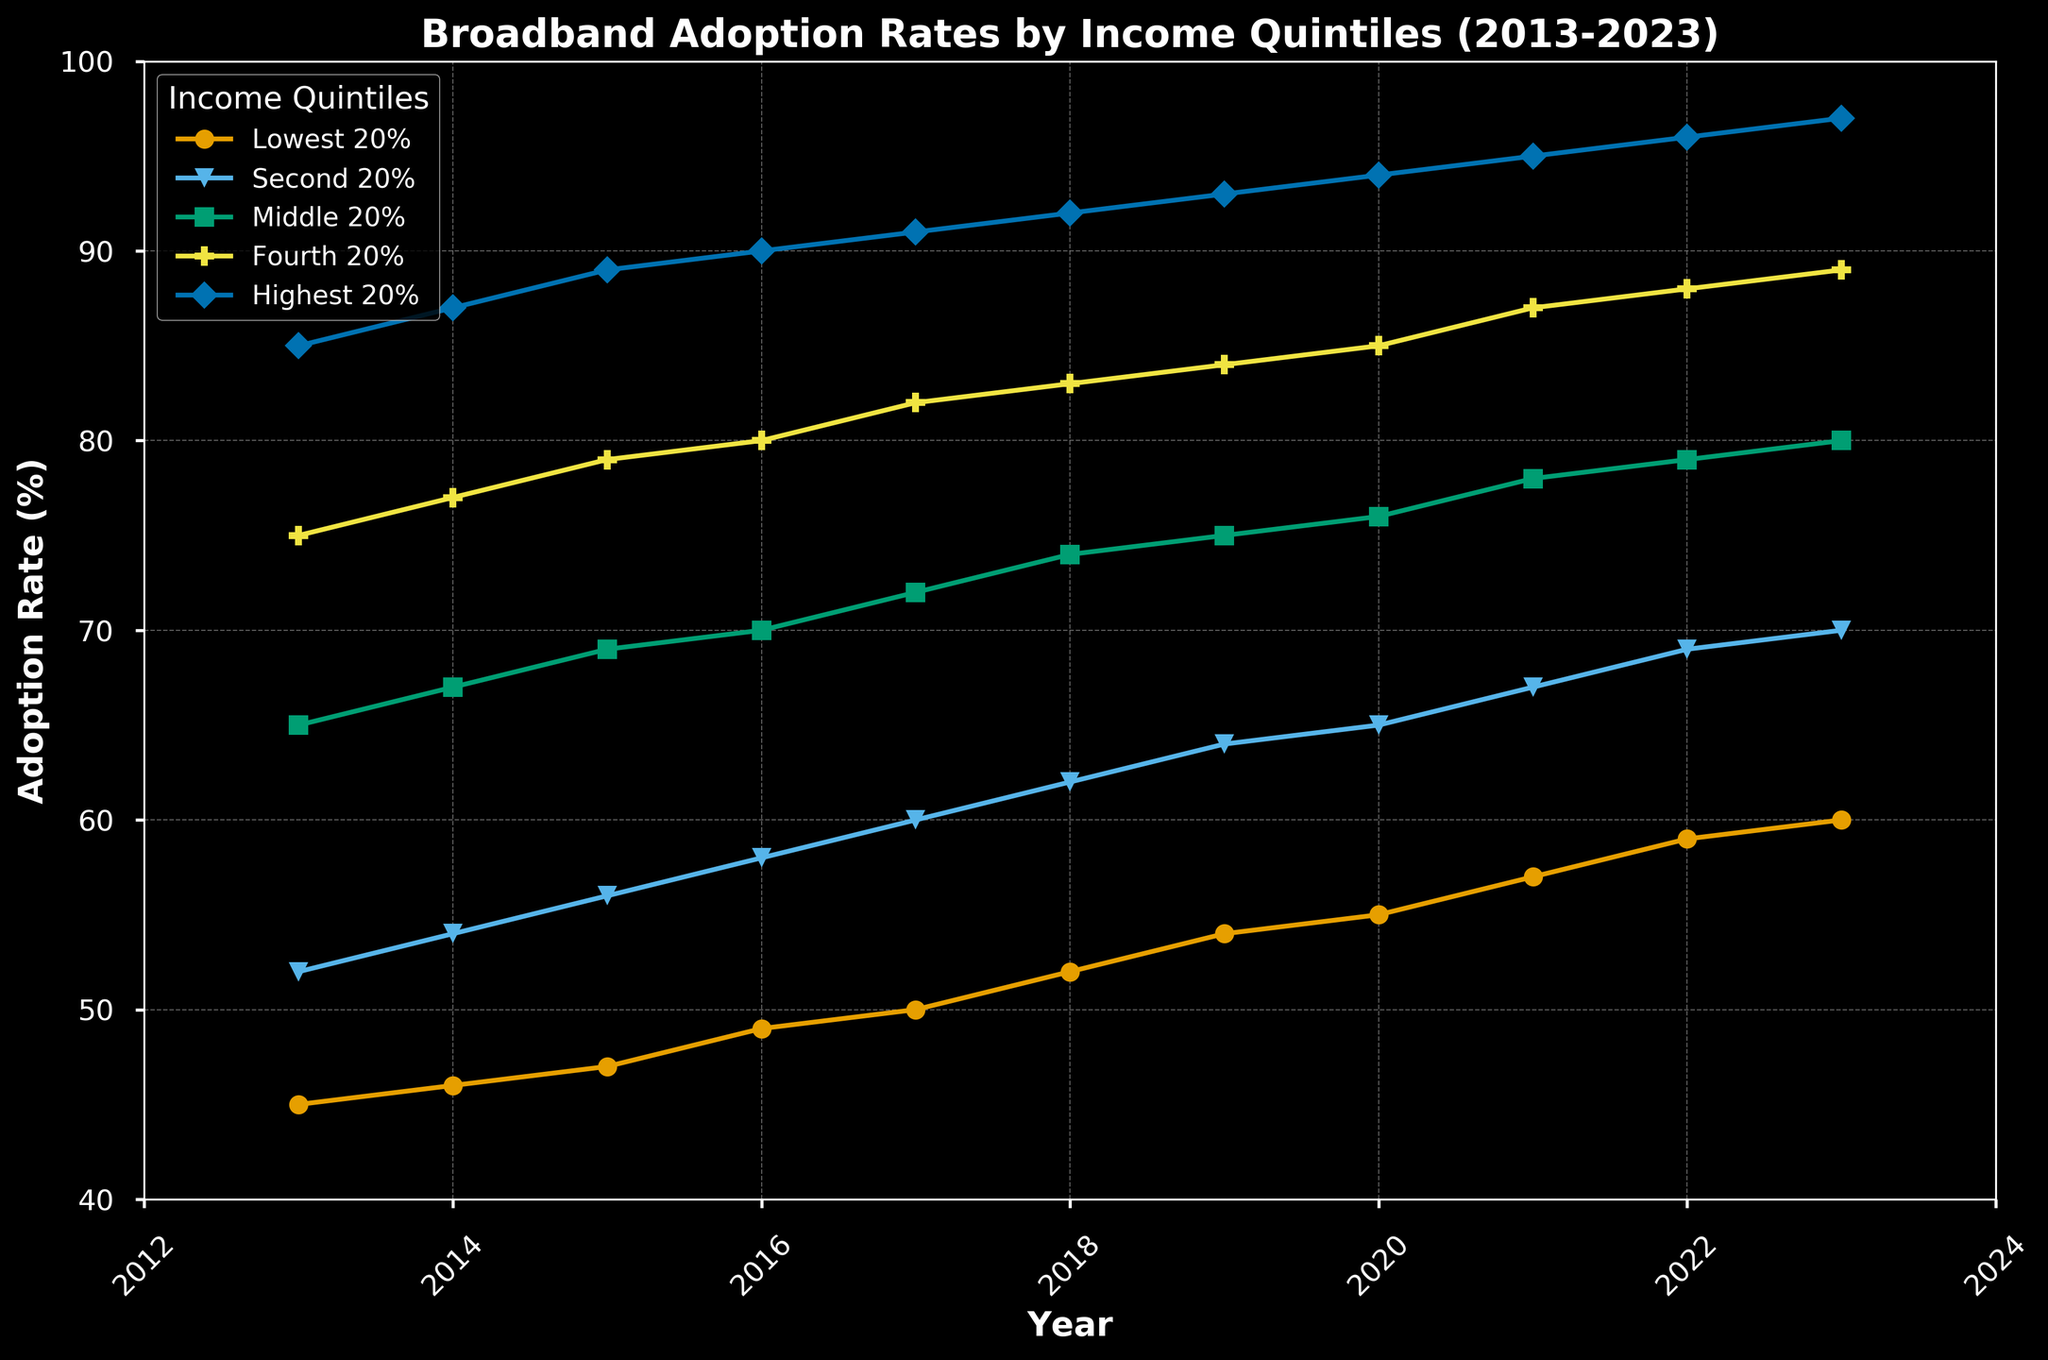What is the adoption rate of the Highest 20% income quintile in 2023? Locate the line representing the Highest 20% income quintile (colored blue) and identify its endpoint in 2023. The adoption rate is shown at the topmost point.
Answer: 97% How much did the adoption rate for the Lowest 20% income quintile increase from 2013 to 2023? Find the start and end points of the line representing the Lowest 20% income quintile (colored orange). The adoption rate increases from 45% in 2013 to 60% in 2023. Compute the difference: 60% - 45% = 15%.
Answer: 15% Which income quintile showed the highest increase in adoption rate over the decade? Compare the vertical distance between the start and end points of each line (each income quintile) over the decade. The Highest 20% increased by 12% (97% - 85%), while the Lowest 20% increased by 15% (60% - 45%). The Lowest 20% shows the highest increase.
Answer: Lowest 20% What is the average adoption rate across all quintiles in 2023? Add the adoption rates for each quintile in 2023: 60% + 70% + 80% + 89% + 97% = 396%. Then, divide by the number of quintiles (5) for the average: 396% / 5 = 79.2%.
Answer: 79.2% Which year saw the Highest 20% income quintile's adoption rate surpass 90% for the first time? Track the line representing the Highest 20% income quintile. It surpasses 90% between the markers for 2015 and 2016. Cross-check, and it reaches 91% in 2017.
Answer: 2017 How does the adoption rate of the Middle 20% income quintile in 2018 compare to the Fourth 20% in 2016? Identify the points for 74% (Middle 20% in 2018) and 80% (Fourth 20% in 2016) according to their respective markers and colors. The Fourth 20% in 2016 has a higher adoption rate than the Middle 20% in 2018.
Answer: Fourth 20% in 2016 is higher What is the median adoption rate for the Second 20% income quintile from 2013 to 2023? List adoption rates for each year: 52%, 54%, 56%, 58%, 60%, 62%, 64%, 65%, 67%, 69%, and 70%. The median value is the middle value in this ordered list. With an odd number of data points (11), 60% is the middle value.
Answer: 60% Which income quintile had the smallest increase in broadband adoption rate over the decade? Compare the increase for each quintile: Lowest 20% (15%), Second 20% (18%), Middle 20% (15%), Fourth 20% (14%), Highest 20% (12%). The Highest 20% had the smallest increase.
Answer: Highest 20% 